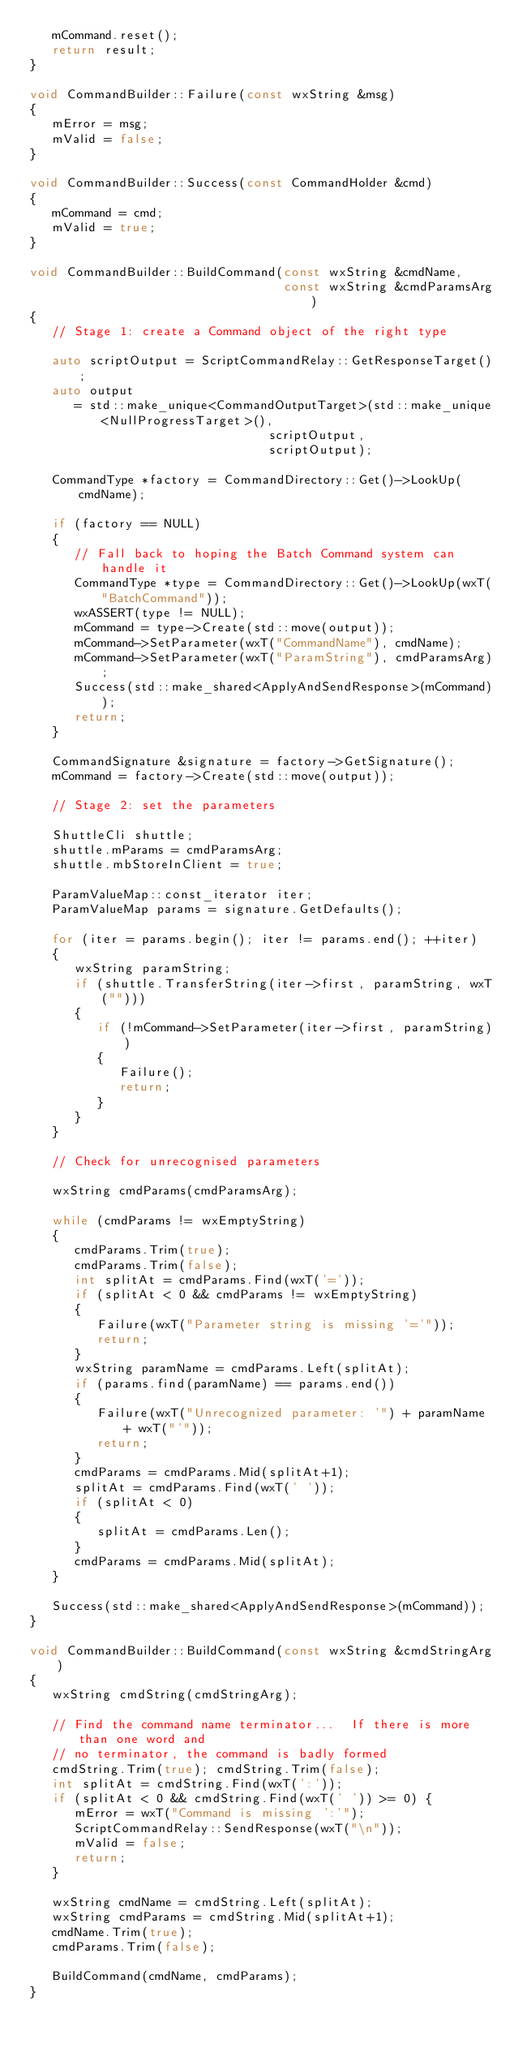Convert code to text. <code><loc_0><loc_0><loc_500><loc_500><_C++_>   mCommand.reset();
   return result;
}

void CommandBuilder::Failure(const wxString &msg)
{
   mError = msg;
   mValid = false;
}

void CommandBuilder::Success(const CommandHolder &cmd)
{
   mCommand = cmd;
   mValid = true;
}

void CommandBuilder::BuildCommand(const wxString &cmdName,
                                  const wxString &cmdParamsArg)
{
   // Stage 1: create a Command object of the right type

   auto scriptOutput = ScriptCommandRelay::GetResponseTarget();
   auto output
      = std::make_unique<CommandOutputTarget>(std::make_unique<NullProgressTarget>(),
                                scriptOutput,
                                scriptOutput);

   CommandType *factory = CommandDirectory::Get()->LookUp(cmdName);

   if (factory == NULL)
   {
      // Fall back to hoping the Batch Command system can handle it
      CommandType *type = CommandDirectory::Get()->LookUp(wxT("BatchCommand"));
      wxASSERT(type != NULL);
      mCommand = type->Create(std::move(output));
      mCommand->SetParameter(wxT("CommandName"), cmdName);
      mCommand->SetParameter(wxT("ParamString"), cmdParamsArg);
      Success(std::make_shared<ApplyAndSendResponse>(mCommand));
      return;
   }

   CommandSignature &signature = factory->GetSignature();
   mCommand = factory->Create(std::move(output));

   // Stage 2: set the parameters

   ShuttleCli shuttle;
   shuttle.mParams = cmdParamsArg;
   shuttle.mbStoreInClient = true;

   ParamValueMap::const_iterator iter;
   ParamValueMap params = signature.GetDefaults();

   for (iter = params.begin(); iter != params.end(); ++iter)
   {
      wxString paramString;
      if (shuttle.TransferString(iter->first, paramString, wxT("")))
      {
         if (!mCommand->SetParameter(iter->first, paramString))
         {
            Failure();
            return;
         }
      }
   }

   // Check for unrecognised parameters

   wxString cmdParams(cmdParamsArg);

   while (cmdParams != wxEmptyString)
   {
      cmdParams.Trim(true);
      cmdParams.Trim(false);
      int splitAt = cmdParams.Find(wxT('='));
      if (splitAt < 0 && cmdParams != wxEmptyString)
      {
         Failure(wxT("Parameter string is missing '='"));
         return;
      }
      wxString paramName = cmdParams.Left(splitAt);
      if (params.find(paramName) == params.end())
      {
         Failure(wxT("Unrecognized parameter: '") + paramName + wxT("'"));
         return;
      }
      cmdParams = cmdParams.Mid(splitAt+1);
      splitAt = cmdParams.Find(wxT(' '));
      if (splitAt < 0)
      {
         splitAt = cmdParams.Len();
      }
      cmdParams = cmdParams.Mid(splitAt);
   }

   Success(std::make_shared<ApplyAndSendResponse>(mCommand));
}

void CommandBuilder::BuildCommand(const wxString &cmdStringArg)
{
   wxString cmdString(cmdStringArg);

   // Find the command name terminator...  If there is more than one word and
   // no terminator, the command is badly formed
   cmdString.Trim(true); cmdString.Trim(false);
   int splitAt = cmdString.Find(wxT(':'));
   if (splitAt < 0 && cmdString.Find(wxT(' ')) >= 0) {
      mError = wxT("Command is missing ':'");
      ScriptCommandRelay::SendResponse(wxT("\n"));
      mValid = false;
      return;
   }

   wxString cmdName = cmdString.Left(splitAt);
   wxString cmdParams = cmdString.Mid(splitAt+1);
   cmdName.Trim(true);
   cmdParams.Trim(false);

   BuildCommand(cmdName, cmdParams);
}
</code> 